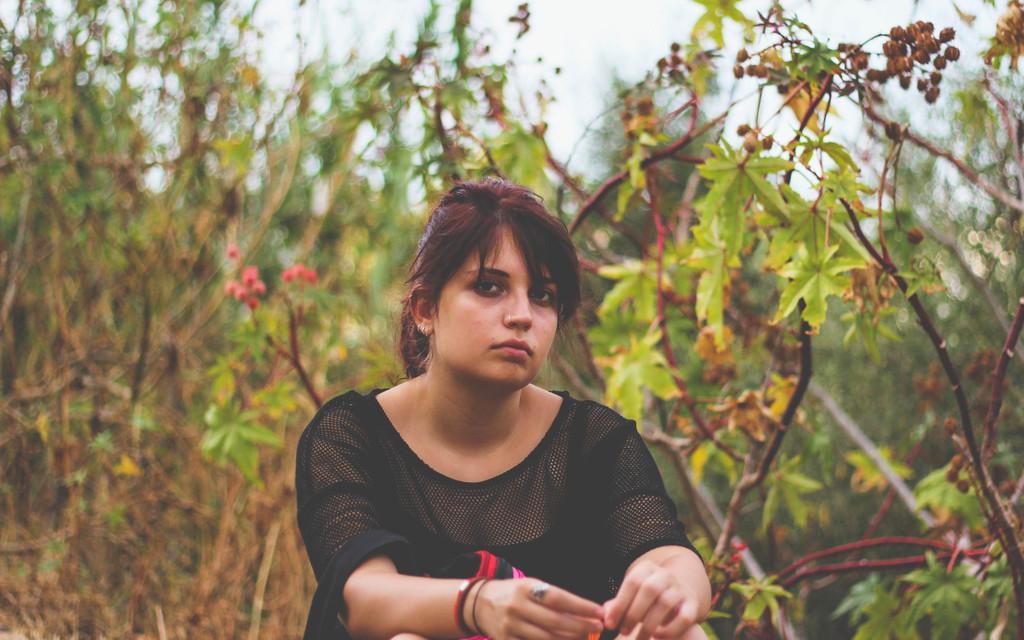Describe this image in one or two sentences. In the foreground of the picture I can see a woman wearing a black color top. In the background, I can see the plants. 